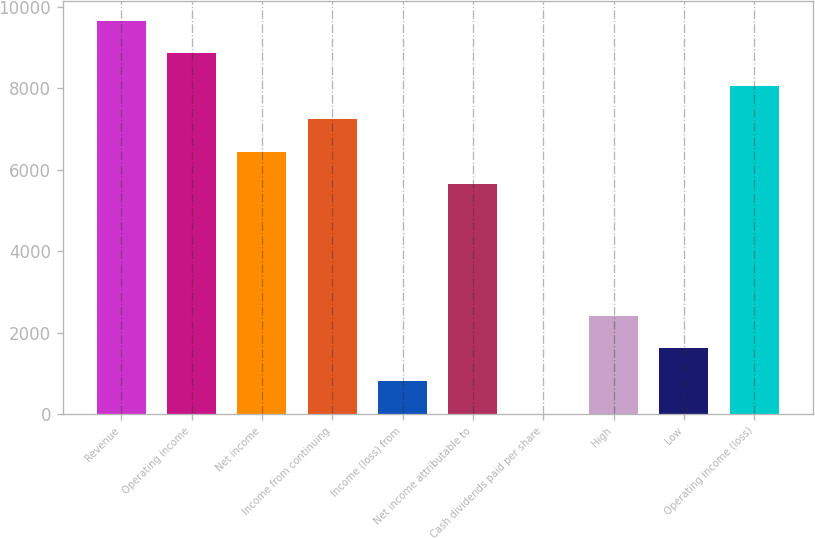Convert chart. <chart><loc_0><loc_0><loc_500><loc_500><bar_chart><fcel>Revenue<fcel>Operating income<fcel>Net income<fcel>Income from continuing<fcel>Income (loss) from<fcel>Net income attributable to<fcel>Cash dividends paid per share<fcel>High<fcel>Low<fcel>Operating income (loss)<nl><fcel>9661.15<fcel>8856.06<fcel>6440.82<fcel>7245.9<fcel>805.24<fcel>5635.74<fcel>0.15<fcel>2415.41<fcel>1610.33<fcel>8050.98<nl></chart> 